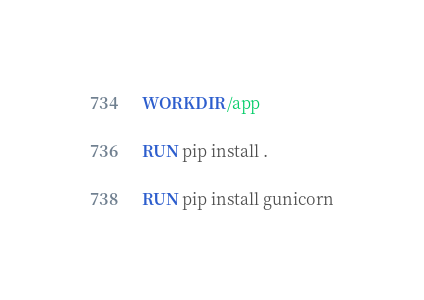Convert code to text. <code><loc_0><loc_0><loc_500><loc_500><_Dockerfile_>WORKDIR /app

RUN pip install .

RUN pip install gunicorn
</code> 